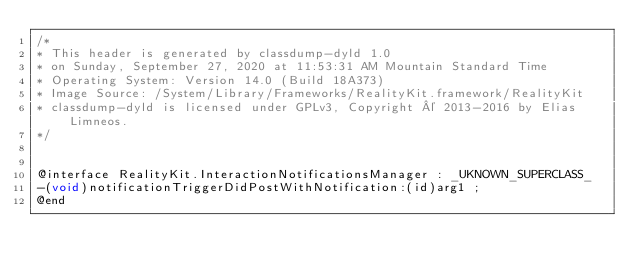Convert code to text. <code><loc_0><loc_0><loc_500><loc_500><_C_>/*
* This header is generated by classdump-dyld 1.0
* on Sunday, September 27, 2020 at 11:53:31 AM Mountain Standard Time
* Operating System: Version 14.0 (Build 18A373)
* Image Source: /System/Library/Frameworks/RealityKit.framework/RealityKit
* classdump-dyld is licensed under GPLv3, Copyright © 2013-2016 by Elias Limneos.
*/


@interface RealityKit.InteractionNotificationsManager : _UKNOWN_SUPERCLASS_
-(void)notificationTriggerDidPostWithNotification:(id)arg1 ;
@end

</code> 